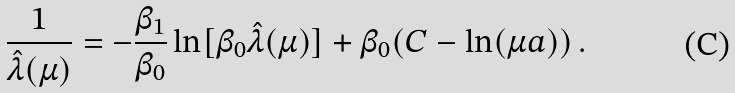<formula> <loc_0><loc_0><loc_500><loc_500>\frac { 1 } { \hat { \lambda } ( \mu ) } = - \frac { \beta _ { 1 } } { \beta _ { 0 } } \ln [ \beta _ { 0 } \hat { \lambda } ( \mu ) ] + \beta _ { 0 } ( C - \ln ( \mu a ) ) \, .</formula> 